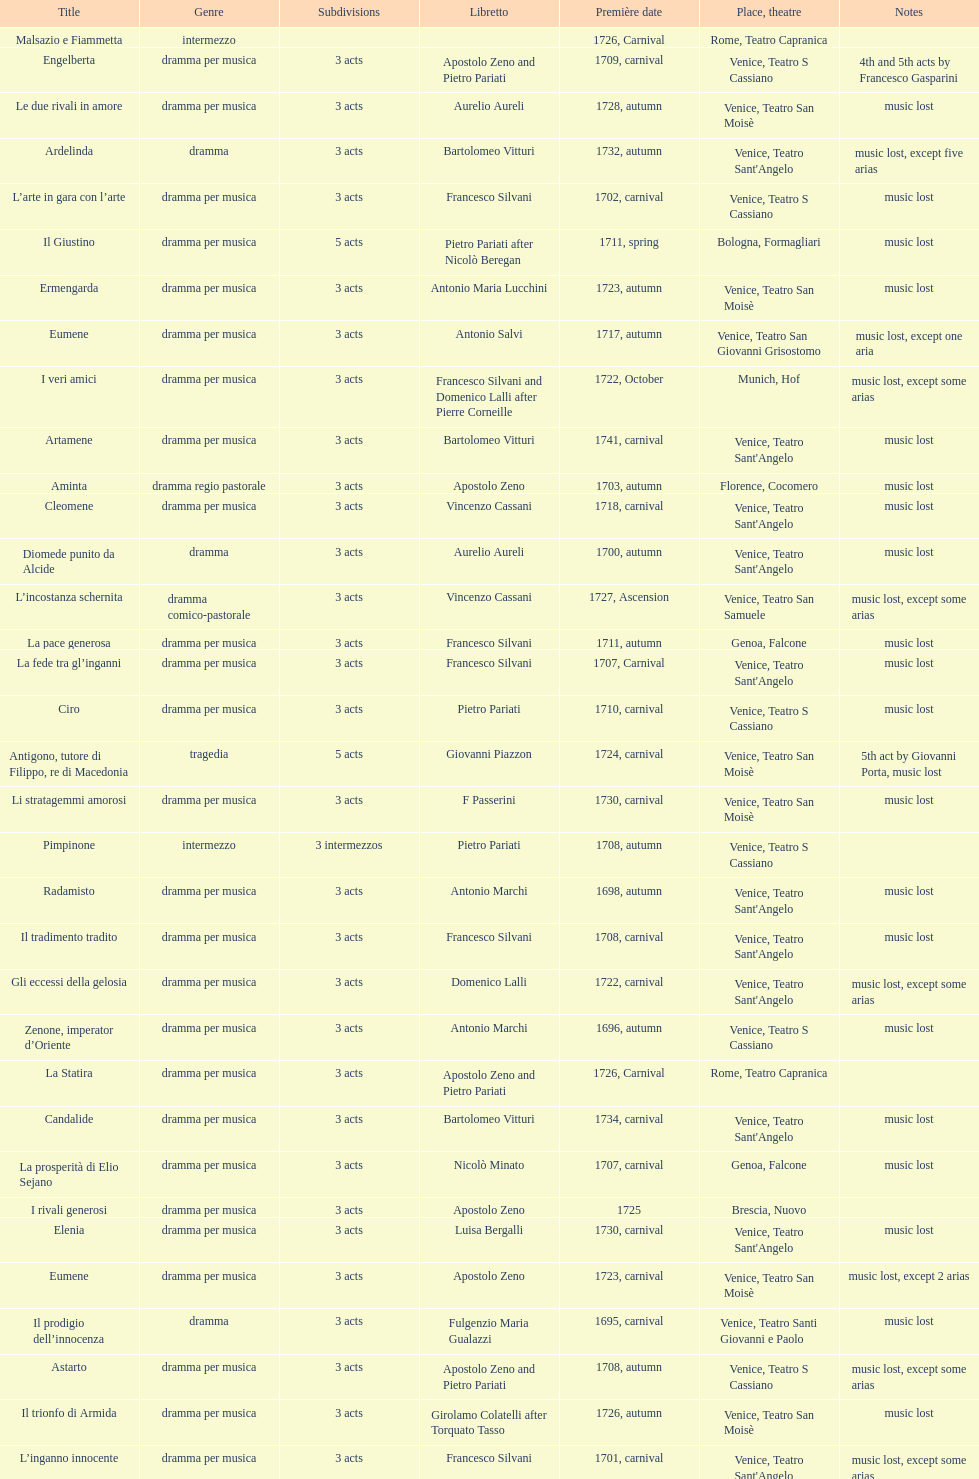What is the count of acts in il giustino? 5. 